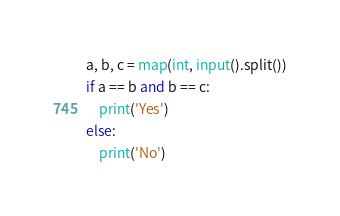Convert code to text. <code><loc_0><loc_0><loc_500><loc_500><_Python_>a, b, c = map(int, input().split())
if a == b and b == c:
	print('Yes')
else:
	print('No')</code> 